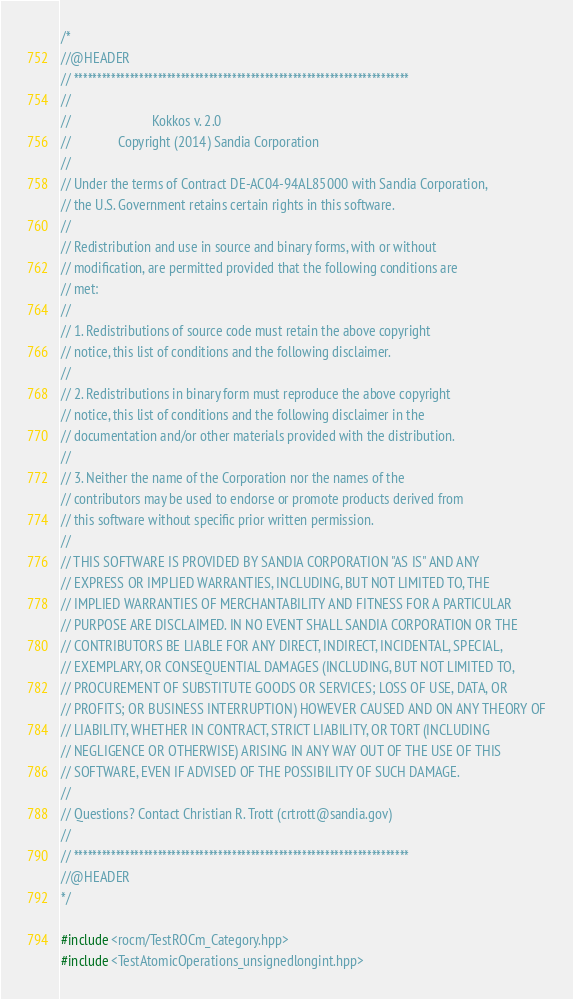<code> <loc_0><loc_0><loc_500><loc_500><_C++_>/*
//@HEADER
// ************************************************************************
//
//                        Kokkos v. 2.0
//              Copyright (2014) Sandia Corporation
//
// Under the terms of Contract DE-AC04-94AL85000 with Sandia Corporation,
// the U.S. Government retains certain rights in this software.
//
// Redistribution and use in source and binary forms, with or without
// modification, are permitted provided that the following conditions are
// met:
//
// 1. Redistributions of source code must retain the above copyright
// notice, this list of conditions and the following disclaimer.
//
// 2. Redistributions in binary form must reproduce the above copyright
// notice, this list of conditions and the following disclaimer in the
// documentation and/or other materials provided with the distribution.
//
// 3. Neither the name of the Corporation nor the names of the
// contributors may be used to endorse or promote products derived from
// this software without specific prior written permission.
//
// THIS SOFTWARE IS PROVIDED BY SANDIA CORPORATION "AS IS" AND ANY
// EXPRESS OR IMPLIED WARRANTIES, INCLUDING, BUT NOT LIMITED TO, THE
// IMPLIED WARRANTIES OF MERCHANTABILITY AND FITNESS FOR A PARTICULAR
// PURPOSE ARE DISCLAIMED. IN NO EVENT SHALL SANDIA CORPORATION OR THE
// CONTRIBUTORS BE LIABLE FOR ANY DIRECT, INDIRECT, INCIDENTAL, SPECIAL,
// EXEMPLARY, OR CONSEQUENTIAL DAMAGES (INCLUDING, BUT NOT LIMITED TO,
// PROCUREMENT OF SUBSTITUTE GOODS OR SERVICES; LOSS OF USE, DATA, OR
// PROFITS; OR BUSINESS INTERRUPTION) HOWEVER CAUSED AND ON ANY THEORY OF
// LIABILITY, WHETHER IN CONTRACT, STRICT LIABILITY, OR TORT (INCLUDING
// NEGLIGENCE OR OTHERWISE) ARISING IN ANY WAY OUT OF THE USE OF THIS
// SOFTWARE, EVEN IF ADVISED OF THE POSSIBILITY OF SUCH DAMAGE.
//
// Questions? Contact Christian R. Trott (crtrott@sandia.gov)
//
// ************************************************************************
//@HEADER
*/

#include <rocm/TestROCm_Category.hpp>
#include <TestAtomicOperations_unsignedlongint.hpp>
</code> 